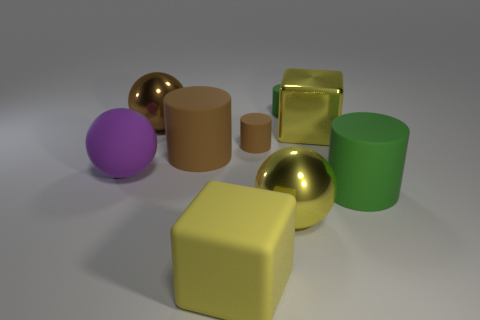What number of large purple balls are there?
Keep it short and to the point. 1. There is a large metal thing that is right of the large yellow metal object that is in front of the big cylinder that is behind the big purple object; what color is it?
Your answer should be very brief. Yellow. Is the number of large green cylinders less than the number of tiny green metal objects?
Keep it short and to the point. No. What is the color of the other small thing that is the same shape as the small brown rubber object?
Your response must be concise. Green. There is another sphere that is the same material as the yellow sphere; what is its color?
Give a very brief answer. Brown. How many other shiny things have the same size as the brown metallic thing?
Provide a short and direct response. 2. What is the big brown ball made of?
Provide a succinct answer. Metal. Is the number of big purple balls greater than the number of purple metal spheres?
Your response must be concise. Yes. Is the small brown matte thing the same shape as the big green object?
Your answer should be very brief. Yes. Does the sphere in front of the purple object have the same color as the large cube that is behind the purple rubber sphere?
Provide a short and direct response. Yes. 